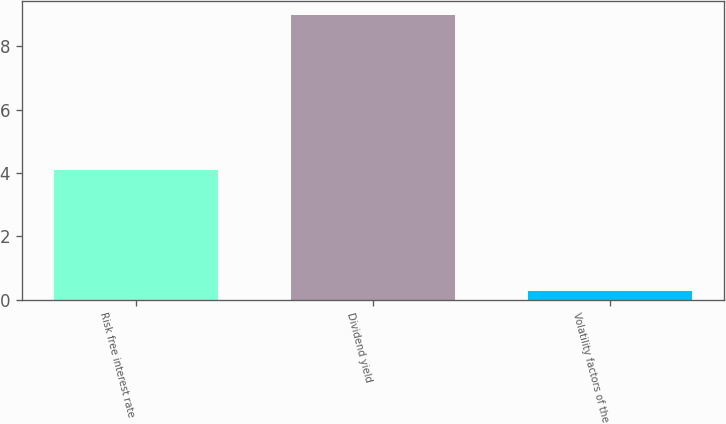Convert chart. <chart><loc_0><loc_0><loc_500><loc_500><bar_chart><fcel>Risk free interest rate<fcel>Dividend yield<fcel>Volatility factors of the<nl><fcel>4.1<fcel>9<fcel>0.28<nl></chart> 